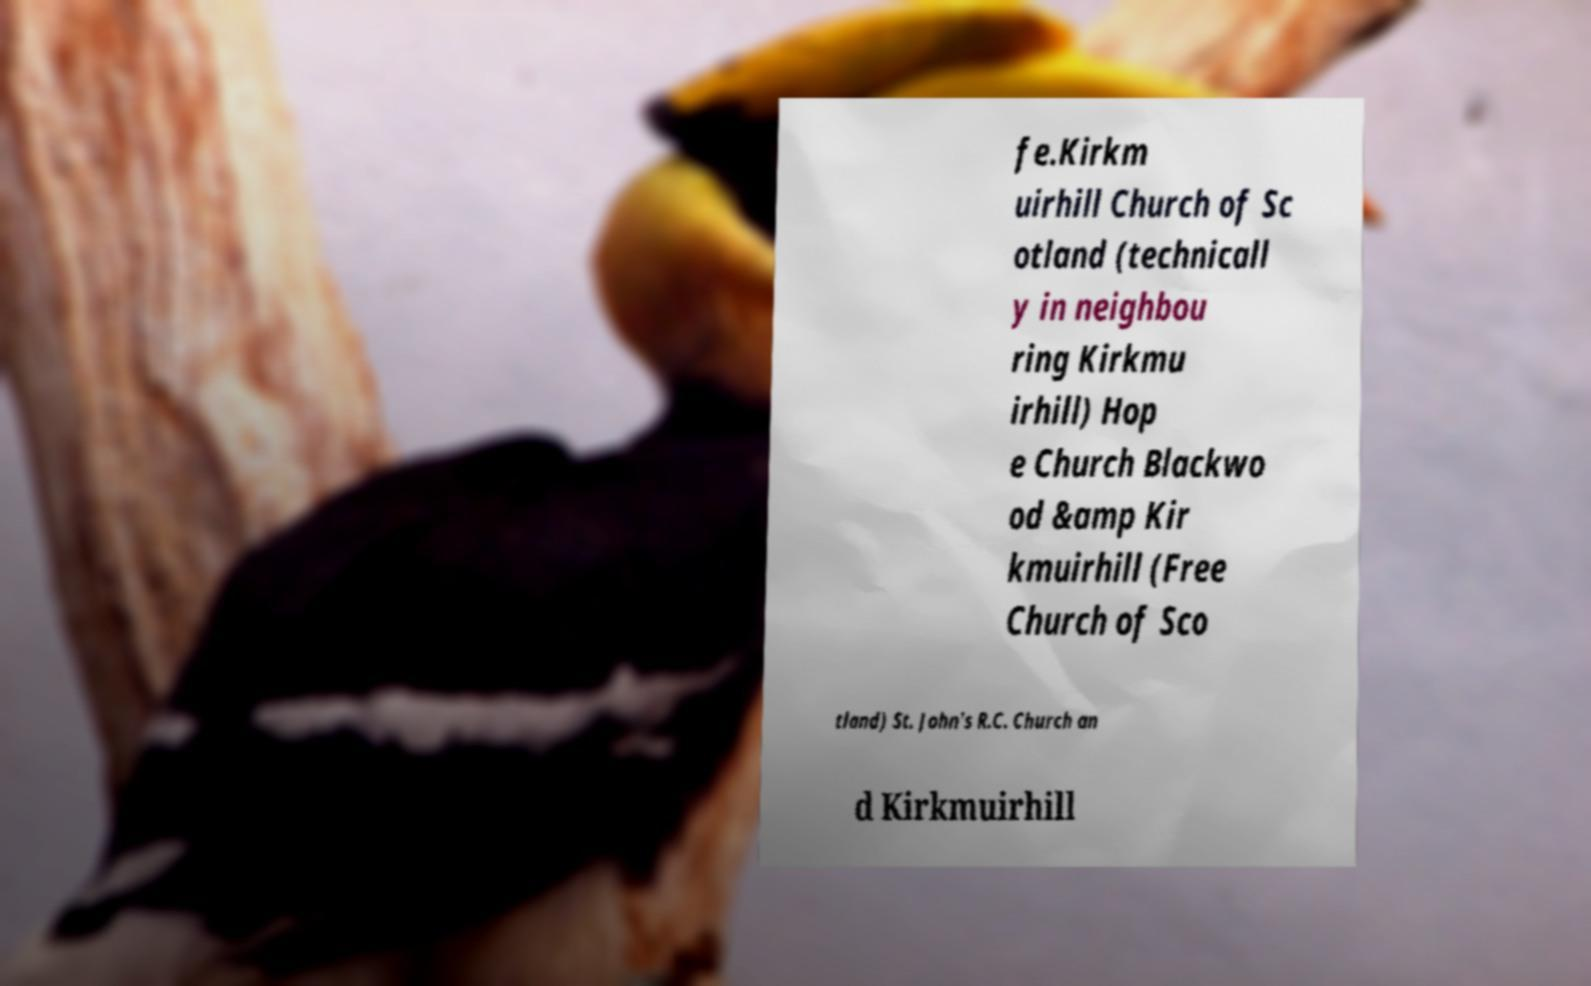Please identify and transcribe the text found in this image. fe.Kirkm uirhill Church of Sc otland (technicall y in neighbou ring Kirkmu irhill) Hop e Church Blackwo od &amp Kir kmuirhill (Free Church of Sco tland) St. John's R.C. Church an d Kirkmuirhill 